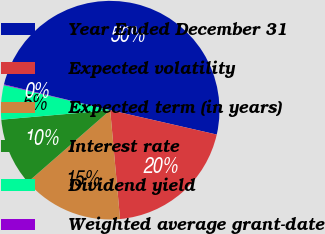Convert chart. <chart><loc_0><loc_0><loc_500><loc_500><pie_chart><fcel>Year Ended December 31<fcel>Expected volatility<fcel>Expected term (in years)<fcel>Interest rate<fcel>Dividend yield<fcel>Weighted average grant-date<nl><fcel>49.79%<fcel>19.98%<fcel>15.01%<fcel>10.04%<fcel>5.07%<fcel>0.1%<nl></chart> 